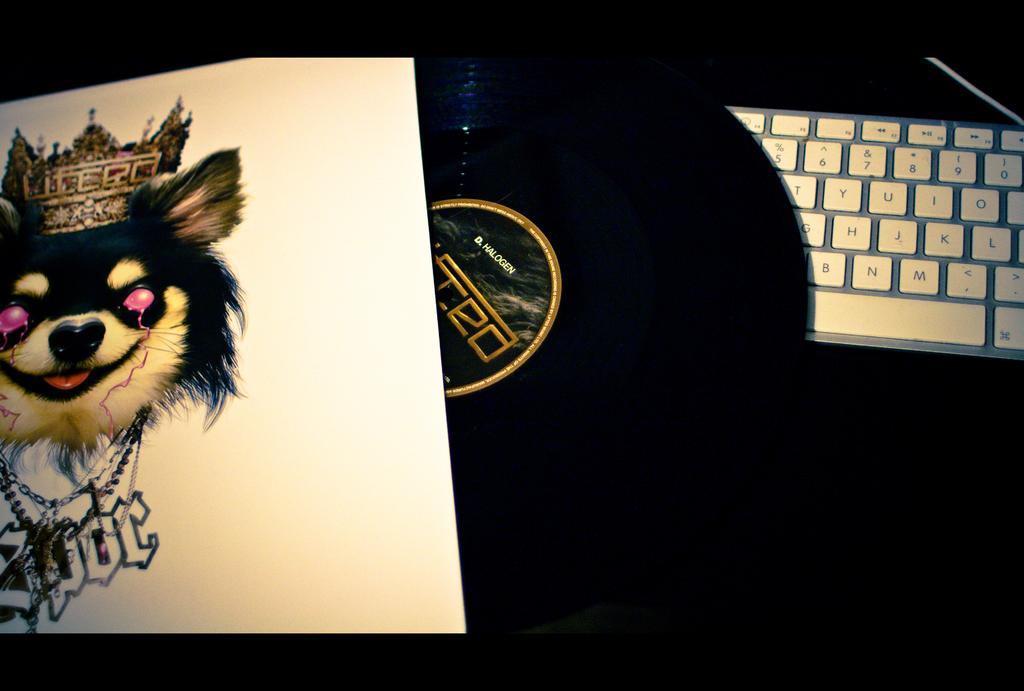What is the main piece of furniture in the image? There is a table in the image. What object related to music is on the table? There is a keyboard on the table. What type of music storage device is on the table? There is a music disc on the table. What other item can be seen on the table? There is a paper with a dog's face on the table. What type of string is used to play the keyboard in the image? The keyboard in the image is played using keys, not strings. 